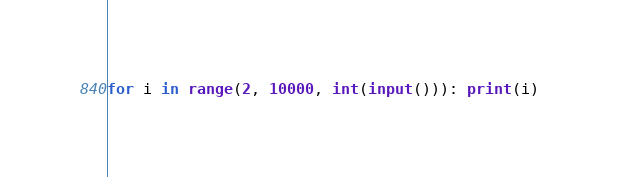Convert code to text. <code><loc_0><loc_0><loc_500><loc_500><_Python_>
for i in range(2, 10000, int(input())): print(i)
</code> 